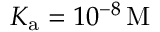<formula> <loc_0><loc_0><loc_500><loc_500>K _ { a } = 1 0 ^ { - 8 } \, M</formula> 